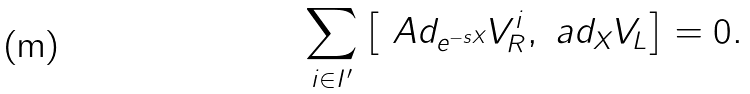Convert formula to latex. <formula><loc_0><loc_0><loc_500><loc_500>\sum _ { i \in I ^ { \prime } } \left [ \ A d _ { e ^ { - s X } } V _ { R } ^ { i } , \ a d _ { X } V _ { L } \right ] = 0 .</formula> 